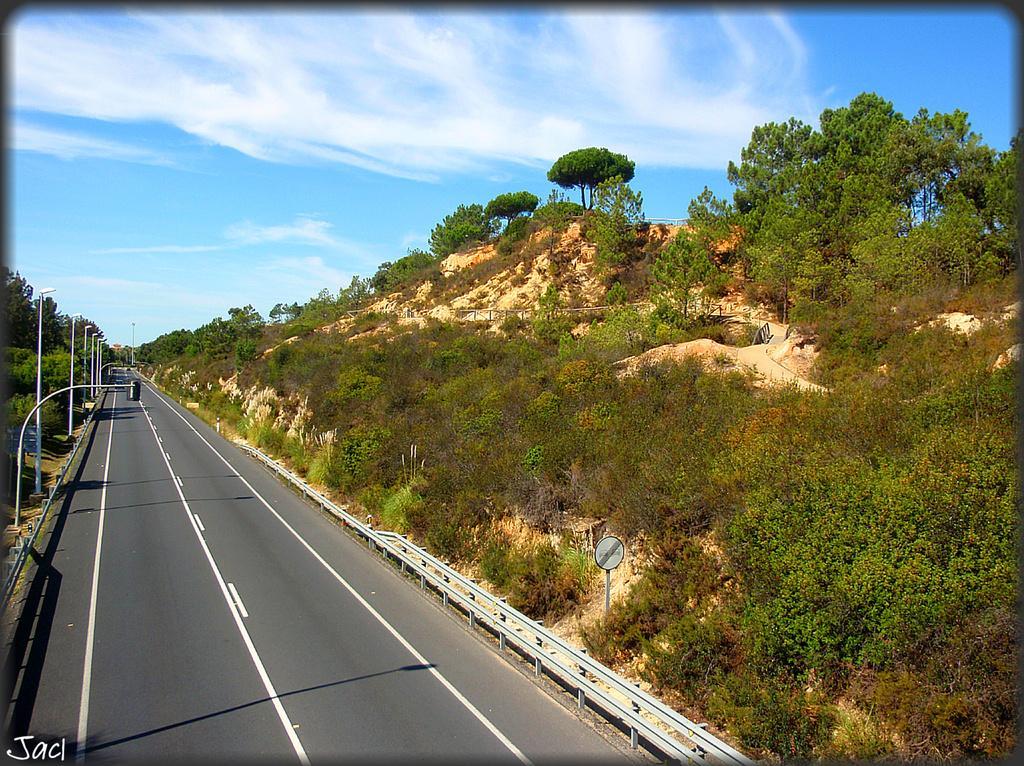Could you give a brief overview of what you see in this image? This image is clicked on the road. At the bottom, there is a road. On the right, we can see the mountains covered with trees and plants. On the left, there are poles along with lights. At the top, there are clouds in the sky. 